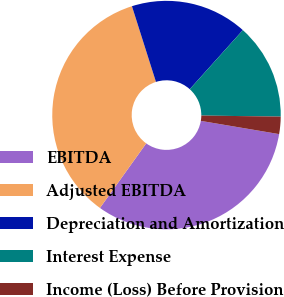Convert chart to OTSL. <chart><loc_0><loc_0><loc_500><loc_500><pie_chart><fcel>EBITDA<fcel>Adjusted EBITDA<fcel>Depreciation and Amortization<fcel>Interest Expense<fcel>Income (Loss) Before Provision<nl><fcel>32.23%<fcel>35.21%<fcel>16.54%<fcel>13.56%<fcel>2.45%<nl></chart> 